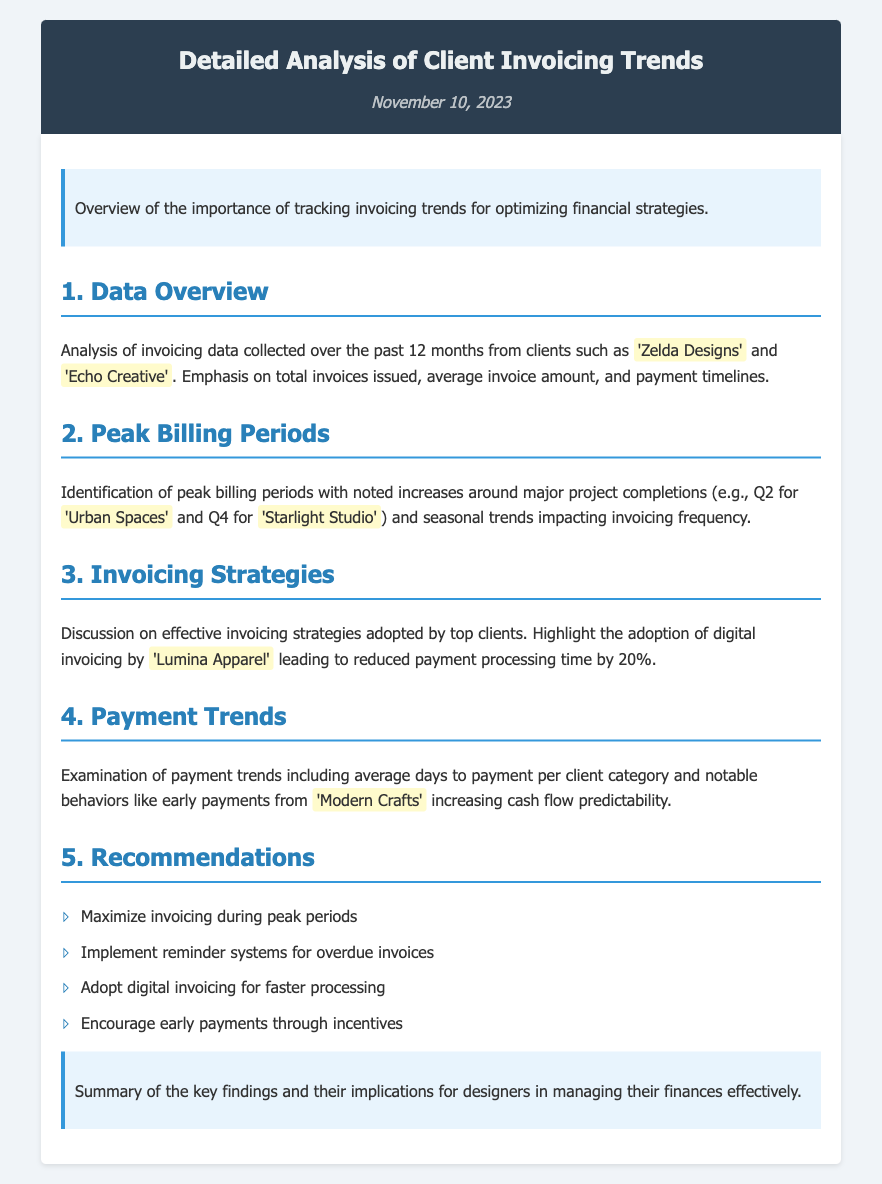What are the names of two clients analyzed in the document? The document mentions two clients: 'Zelda Designs' and 'Echo Creative'.
Answer: 'Zelda Designs', 'Echo Creative' What is the date of the document? The document displays the date as November 10, 2023.
Answer: November 10, 2023 Which quarter is identified as a peak billing period for 'Urban Spaces'? The analysis highlights that Q2 is a peak billing period for 'Urban Spaces'.
Answer: Q2 What technology led to reduced payment processing time for 'Lumina Apparel'? The document states that digital invoicing led to reduced payment processing time by 20% for 'Lumina Apparel'.
Answer: Digital invoicing What recommendation is given to maximize invoicing effectiveness? The recommendation states to maximize invoicing during peak periods.
Answer: Maximize invoicing during peak periods Which client is noted for early payments that increase cash flow predictability? The document mentions 'Modern Crafts' for early payments that improve cash flow predictability.
Answer: 'Modern Crafts' How much was the reduction in payment processing time due to adopting digital invoicing? The document indicates that the reduction was by 20%.
Answer: 20% What is the main focus of the introductory section? The introduction emphasizes the importance of tracking invoicing trends for optimizing financial strategies.
Answer: Importance of tracking invoicing trends 